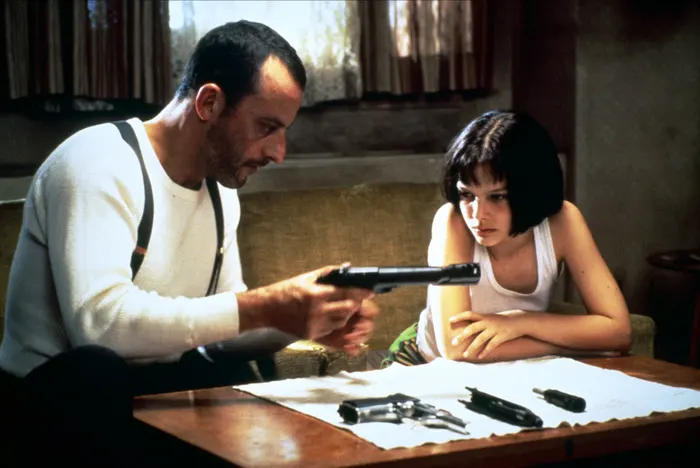Reflect on the characters' expressions and body language. What do these tell us about their emotions and relationship? Léon's composed demeanor and gentle handling of the gun reflect his experience and confidence in his trade, alongside a paternal concern for Mathilda. Mathilda's attentive posture and expression of concentration mixed with concern suggest her mixed emotions: eagerness to learn and underlying worry about the implications of her training. This dynamic indicates a complex relationship built on trust, mentorship, and shared vulnerability. 